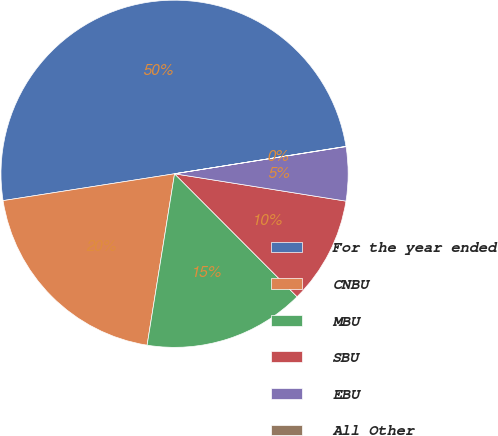Convert chart to OTSL. <chart><loc_0><loc_0><loc_500><loc_500><pie_chart><fcel>For the year ended<fcel>CNBU<fcel>MBU<fcel>SBU<fcel>EBU<fcel>All Other<nl><fcel>49.95%<fcel>20.0%<fcel>15.0%<fcel>10.01%<fcel>5.02%<fcel>0.02%<nl></chart> 